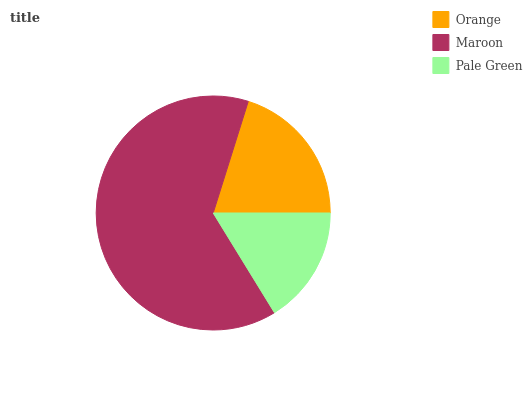Is Pale Green the minimum?
Answer yes or no. Yes. Is Maroon the maximum?
Answer yes or no. Yes. Is Maroon the minimum?
Answer yes or no. No. Is Pale Green the maximum?
Answer yes or no. No. Is Maroon greater than Pale Green?
Answer yes or no. Yes. Is Pale Green less than Maroon?
Answer yes or no. Yes. Is Pale Green greater than Maroon?
Answer yes or no. No. Is Maroon less than Pale Green?
Answer yes or no. No. Is Orange the high median?
Answer yes or no. Yes. Is Orange the low median?
Answer yes or no. Yes. Is Maroon the high median?
Answer yes or no. No. Is Maroon the low median?
Answer yes or no. No. 